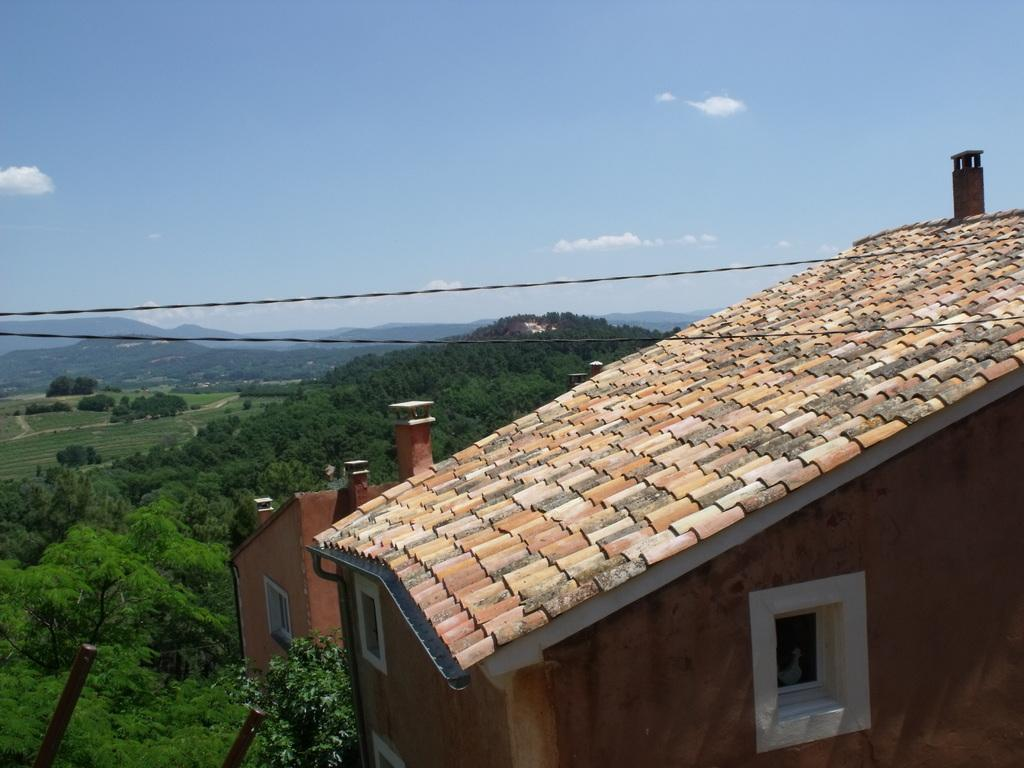What can be seen in the sky in the image? The sky with clouds is visible in the image. What type of structures can be seen in the image? There are cables, hills, and a building present in the image. What type of terrain is visible in the image? The ground and trees are visible in the image. Where can you purchase a ticket for the event in the image? There is no event or ticket present in the image; it features a sky with clouds, cables, hills, a building, the ground, and trees. What type of sidewalk is visible in the image? There is no sidewalk present in the image. 